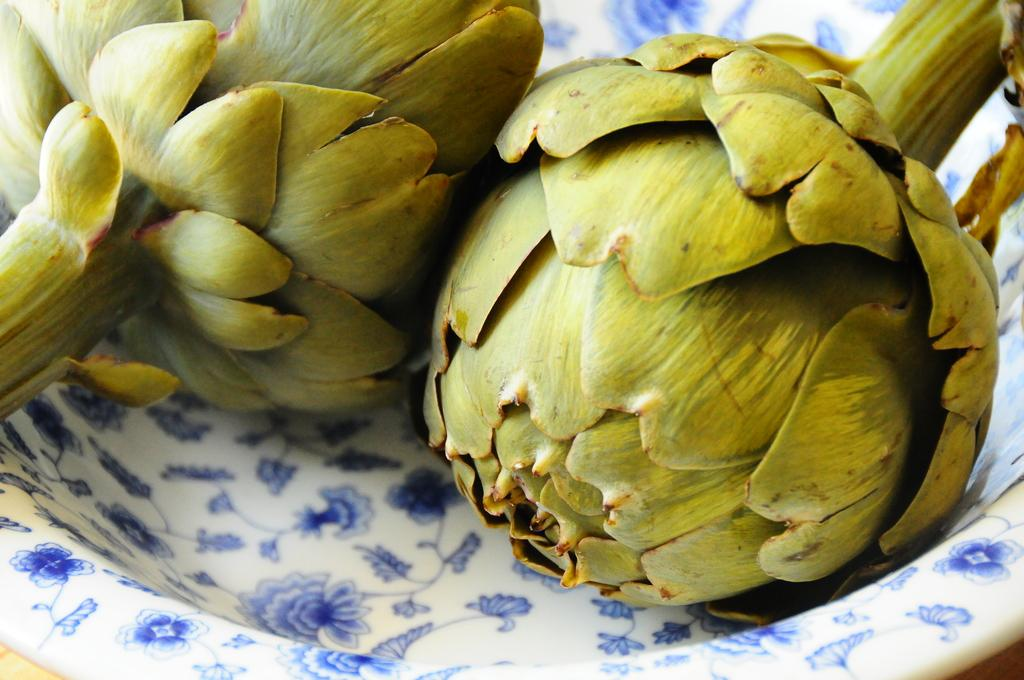What is located in the bowl that is visible in the image? There are plants in a bowl in the image. What type of gate can be seen in the image? There is no gate present in the image; it features plants in a bowl. What holiday is being celebrated in the image? There is no indication of a holiday being celebrated in the image. 